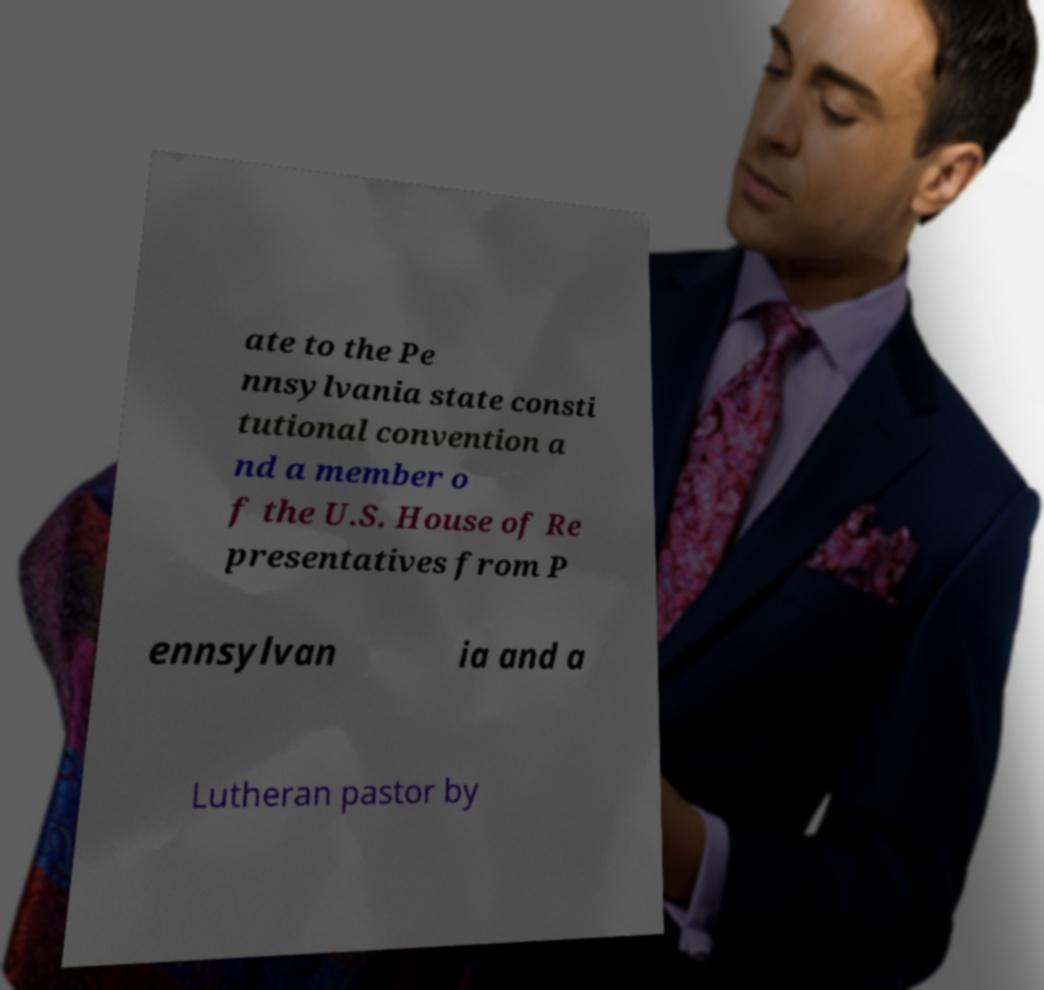Please identify and transcribe the text found in this image. ate to the Pe nnsylvania state consti tutional convention a nd a member o f the U.S. House of Re presentatives from P ennsylvan ia and a Lutheran pastor by 